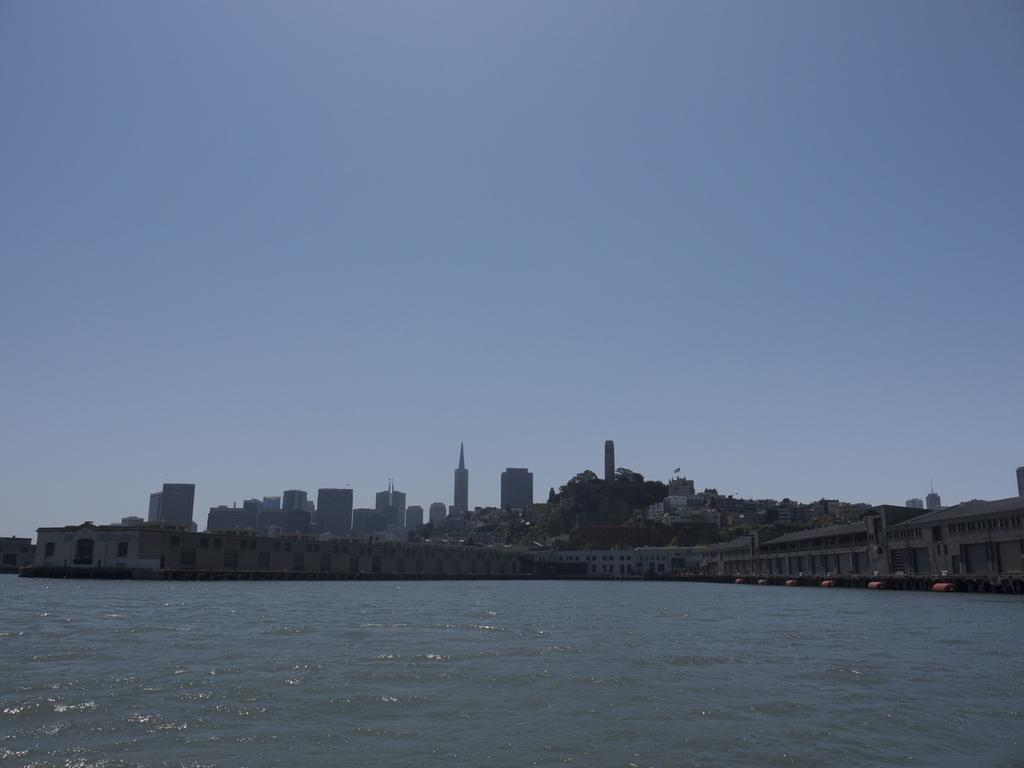What is visible in the image? Water is visible in the image. What can be seen in the background of the image? There are buildings, trees, and the sky visible in the background of the image. What type of wine is being served in the image? There is no wine present in the image; it features water, buildings, trees, and the sky. What brand of jeans can be seen on the person in the image? There is no person or jeans present in the image. 